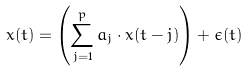Convert formula to latex. <formula><loc_0><loc_0><loc_500><loc_500>x ( t ) = \left ( \sum _ { j = 1 } ^ { p } { a _ { j } \cdot { x ( t - j ) } } \right ) + \epsilon ( t )</formula> 